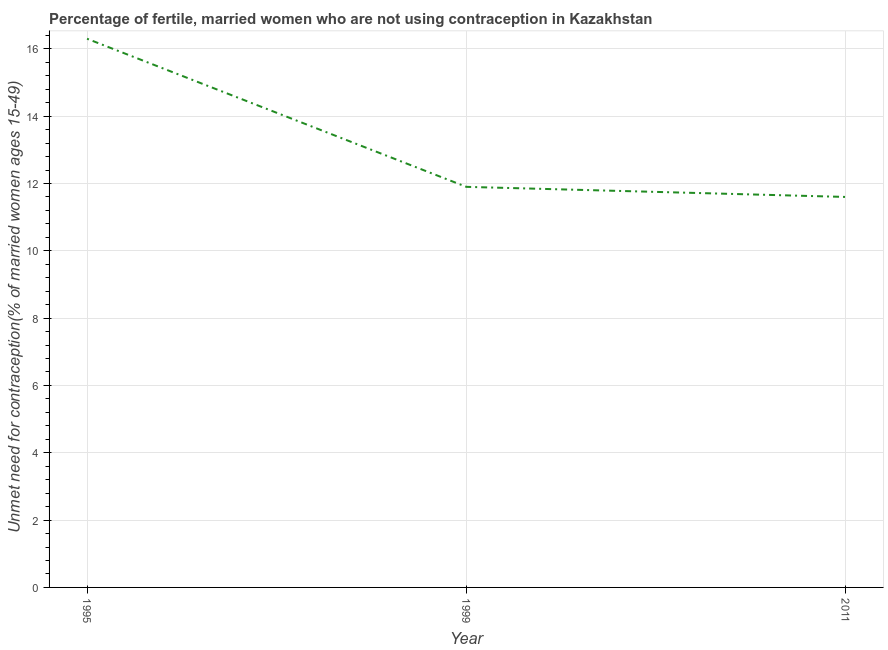Across all years, what is the maximum number of married women who are not using contraception?
Your answer should be very brief. 16.3. Across all years, what is the minimum number of married women who are not using contraception?
Your answer should be compact. 11.6. In which year was the number of married women who are not using contraception maximum?
Your response must be concise. 1995. What is the sum of the number of married women who are not using contraception?
Offer a terse response. 39.8. What is the average number of married women who are not using contraception per year?
Ensure brevity in your answer.  13.27. What is the median number of married women who are not using contraception?
Your response must be concise. 11.9. Do a majority of the years between 1995 and 2011 (inclusive) have number of married women who are not using contraception greater than 11.2 %?
Your response must be concise. Yes. What is the ratio of the number of married women who are not using contraception in 1999 to that in 2011?
Your response must be concise. 1.03. Is the number of married women who are not using contraception in 1999 less than that in 2011?
Give a very brief answer. No. Is the difference between the number of married women who are not using contraception in 1999 and 2011 greater than the difference between any two years?
Your response must be concise. No. What is the difference between the highest and the second highest number of married women who are not using contraception?
Your response must be concise. 4.4. Is the sum of the number of married women who are not using contraception in 1995 and 1999 greater than the maximum number of married women who are not using contraception across all years?
Provide a short and direct response. Yes. What is the difference between the highest and the lowest number of married women who are not using contraception?
Make the answer very short. 4.7. Does the number of married women who are not using contraception monotonically increase over the years?
Give a very brief answer. No. How many lines are there?
Keep it short and to the point. 1. How many years are there in the graph?
Ensure brevity in your answer.  3. Are the values on the major ticks of Y-axis written in scientific E-notation?
Provide a short and direct response. No. Does the graph contain any zero values?
Keep it short and to the point. No. Does the graph contain grids?
Your answer should be very brief. Yes. What is the title of the graph?
Your answer should be compact. Percentage of fertile, married women who are not using contraception in Kazakhstan. What is the label or title of the X-axis?
Make the answer very short. Year. What is the label or title of the Y-axis?
Provide a short and direct response.  Unmet need for contraception(% of married women ages 15-49). What is the  Unmet need for contraception(% of married women ages 15-49) of 1995?
Your answer should be compact. 16.3. What is the  Unmet need for contraception(% of married women ages 15-49) in 1999?
Your response must be concise. 11.9. What is the  Unmet need for contraception(% of married women ages 15-49) in 2011?
Keep it short and to the point. 11.6. What is the difference between the  Unmet need for contraception(% of married women ages 15-49) in 1995 and 2011?
Give a very brief answer. 4.7. What is the ratio of the  Unmet need for contraception(% of married women ages 15-49) in 1995 to that in 1999?
Your answer should be compact. 1.37. What is the ratio of the  Unmet need for contraception(% of married women ages 15-49) in 1995 to that in 2011?
Make the answer very short. 1.41. 